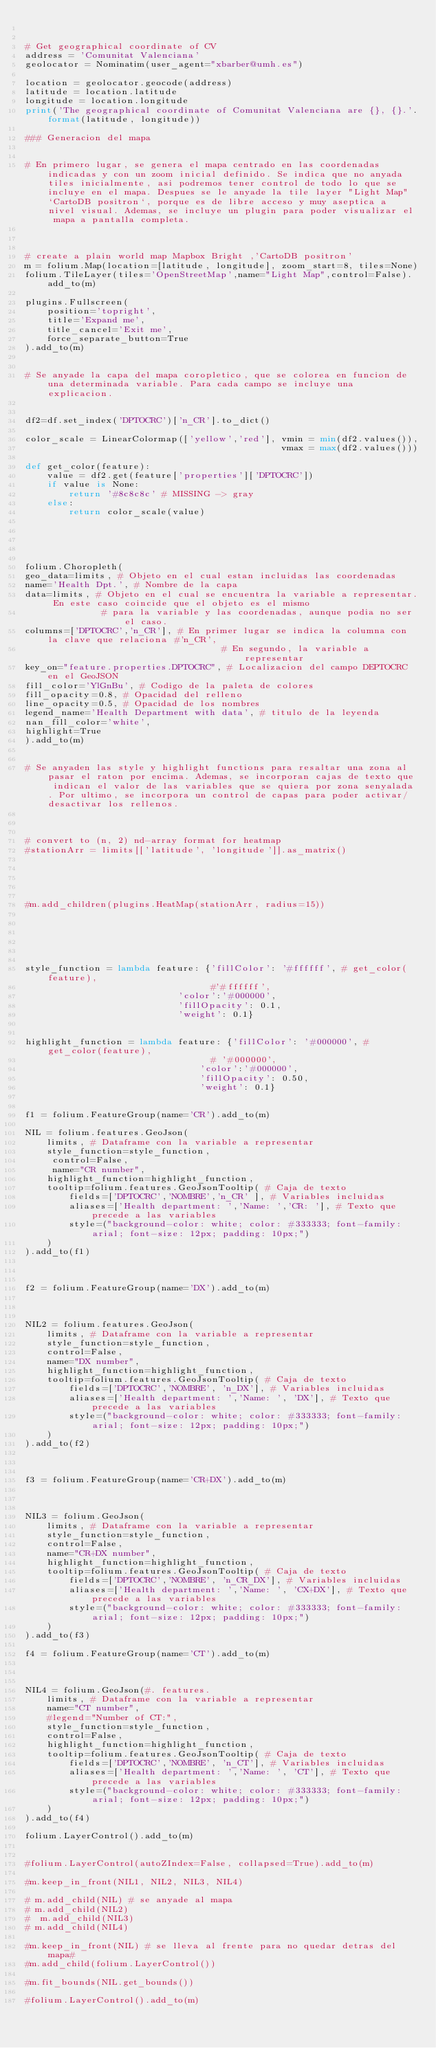Convert code to text. <code><loc_0><loc_0><loc_500><loc_500><_Python_>

# Get geographical coordinate of CV
address = 'Comunitat Valenciana'
geolocator = Nominatim(user_agent="xbarber@umh.es")

location = geolocator.geocode(address)
latitude = location.latitude
longitude = location.longitude
print('The geographical coordinate of Comunitat Valenciana are {}, {}.'.format(latitude, longitude))

### Generacion del mapa


# En primero lugar, se genera el mapa centrado en las coordenadas indicadas y con un zoom inicial definido. Se indica que no anyada tiles inicialmente, asi podremos tener control de todo lo que se incluye en el mapa. Despues se le anyade la tile layer "Light Map" `CartoDB positron`, porque es de libre acceso y muy aseptica a nivel visual. Ademas, se incluye un plugin para poder visualizar el mapa a pantalla completa.



# create a plain world map Mapbox Bright ,'CartoDB positron'
m = folium.Map(location=[latitude, longitude], zoom_start=8, tiles=None) 
folium.TileLayer(tiles='OpenStreetMap',name="Light Map",control=False).add_to(m)

plugins.Fullscreen(
    position='topright',
    title='Expand me',
    title_cancel='Exit me',
    force_separate_button=True
).add_to(m)


# Se anyade la capa del mapa coropletico, que se colorea en funcion de una determinada variable. Para cada campo se incluye una explicacion.


df2=df.set_index('DPTOCRC')['n_CR'].to_dict()

color_scale = LinearColormap(['yellow','red'], vmin = min(df2.values()),
                                               vmax = max(df2.values()))

def get_color(feature):
    value = df2.get(feature['properties']['DPTOCRC'])
    if value is None:
        return '#8c8c8c' # MISSING -> gray
    else:
        return color_scale(value)
    
    



folium.Choropleth(
geo_data=limits, # Objeto en el cual estan incluidas las coordenadas
name='Health Dpt.', # Nombre de la capa
data=limits, # Objeto en el cual se encuentra la variable a representar. En este caso coincide que el objeto es el mismo
              # para la variable y las coordenadas, aunque podia no ser el caso.
columns=['DPTOCRC','n_CR'], # En primer lugar se indica la columna con la clave que relaciona #'n_CR',
                                    # En segundo, la variable a representar
key_on="feature.properties.DPTOCRC", # Localizacion del campo DEPTOCRC en el GeoJSON
fill_color='YlGnBu', # Codigo de la paleta de colores
fill_opacity=0.8, # Opacidad del relleno
line_opacity=0.5, # Opacidad de los nombres
legend_name='Health Department with data', # titulo de la leyenda
nan_fill_color='white',
highlight=True
).add_to(m)


# Se anyaden las style y highlight functions para resaltar una zona al pasar el raton por encima. Ademas, se incorporan cajas de texto que indican el valor de las variables que se quiera por zona senyalada. Por ultimo, se incorpora un control de capas para poder activar/desactivar los rellenos.



# convert to (n, 2) nd-array format for heatmap
#stationArr = limits[['latitude', 'longitude']].as_matrix()





#m.add_children(plugins.HeatMap(stationArr, radius=15)) 






style_function = lambda feature: {'fillColor': '#ffffff', # get_color(feature),
                                  #'#ffffff', 
                            'color':'#000000', 
                            'fillOpacity': 0.1, 
                            'weight': 0.1}


highlight_function = lambda feature: {'fillColor': '#000000', # get_color(feature),
                                  # '#000000', 
                                'color':'#000000', 
                                'fillOpacity': 0.50, 
                                'weight': 0.1}    


f1 = folium.FeatureGroup(name='CR').add_to(m)

NIL = folium.features.GeoJson(
    limits, # Dataframe con la variable a representar
    style_function=style_function, 
     control=False,
     name="CR number",
    highlight_function=highlight_function, 
    tooltip=folium.features.GeoJsonTooltip( # Caja de texto
        fields=['DPTOCRC','NOMBRE','n_CR' ], # Variables incluidas
        aliases=['Health department: ','Name: ','CR: '], # Texto que precede a las variables
        style=("background-color: white; color: #333333; font-family: arial; font-size: 12px; padding: 10px;") 
    )
).add_to(f1)



f2 = folium.FeatureGroup(name='DX').add_to(m)



NIL2 = folium.features.GeoJson(
    limits, # Dataframe con la variable a representar
    style_function=style_function, 
    control=False,
    name="DX number",
    highlight_function=highlight_function, 
    tooltip=folium.features.GeoJsonTooltip( # Caja de texto
        fields=['DPTOCRC','NOMBRE', 'n_DX'], # Variables incluidas
        aliases=['Health department: ','Name: ', 'DX'], # Texto que precede a las variables
        style=("background-color: white; color: #333333; font-family: arial; font-size: 12px; padding: 10px;") 
    )
).add_to(f2)



f3 = folium.FeatureGroup(name='CR+DX').add_to(m)



NIL3 = folium.GeoJson(
    limits, # Dataframe con la variable a representar
    style_function=style_function, 
    control=False,
    name="CR+DX number",
    highlight_function=highlight_function, 
    tooltip=folium.features.GeoJsonTooltip( # Caja de texto
        fields=['DPTOCRC','NOMBRE', 'n_CR_DX'], # Variables incluidas
        aliases=['Health department: ','Name: ', 'CX+DX'], # Texto que precede a las variables
        style=("background-color: white; color: #333333; font-family: arial; font-size: 12px; padding: 10px;") 
    )
).add_to(f3)

f4 = folium.FeatureGroup(name='CT').add_to(m)



NIL4 = folium.GeoJson(#. features.
    limits, # Dataframe con la variable a representar
    name="CT number",
    #legend="Number of CT:",
    style_function=style_function, 
    control=False,
    highlight_function=highlight_function, 
    tooltip=folium.features.GeoJsonTooltip( # Caja de texto
        fields=['DPTOCRC','NOMBRE', 'n_CT'], # Variables incluidas
        aliases=['Health department: ','Name: ', 'CT'], # Texto que precede a las variables
        style=("background-color: white; color: #333333; font-family: arial; font-size: 12px; padding: 10px;") 
    )
).add_to(f4)

folium.LayerControl().add_to(m)

 
#folium.LayerControl(autoZIndex=False, collapsed=True).add_to(m)

#m.keep_in_front(NIL1, NIL2, NIL3, NIL4)

# m.add_child(NIL) # se anyade al mapa
# m.add_child(NIL2)
#  m.add_child(NIL3)
# m.add_child(NIL4)

#m.keep_in_front(NIL) # se lleva al frente para no quedar detras del mapa#
#m.add_child(folium.LayerControl())

#m.fit_bounds(NIL.get_bounds()) 

#folium.LayerControl().add_to(m)</code> 